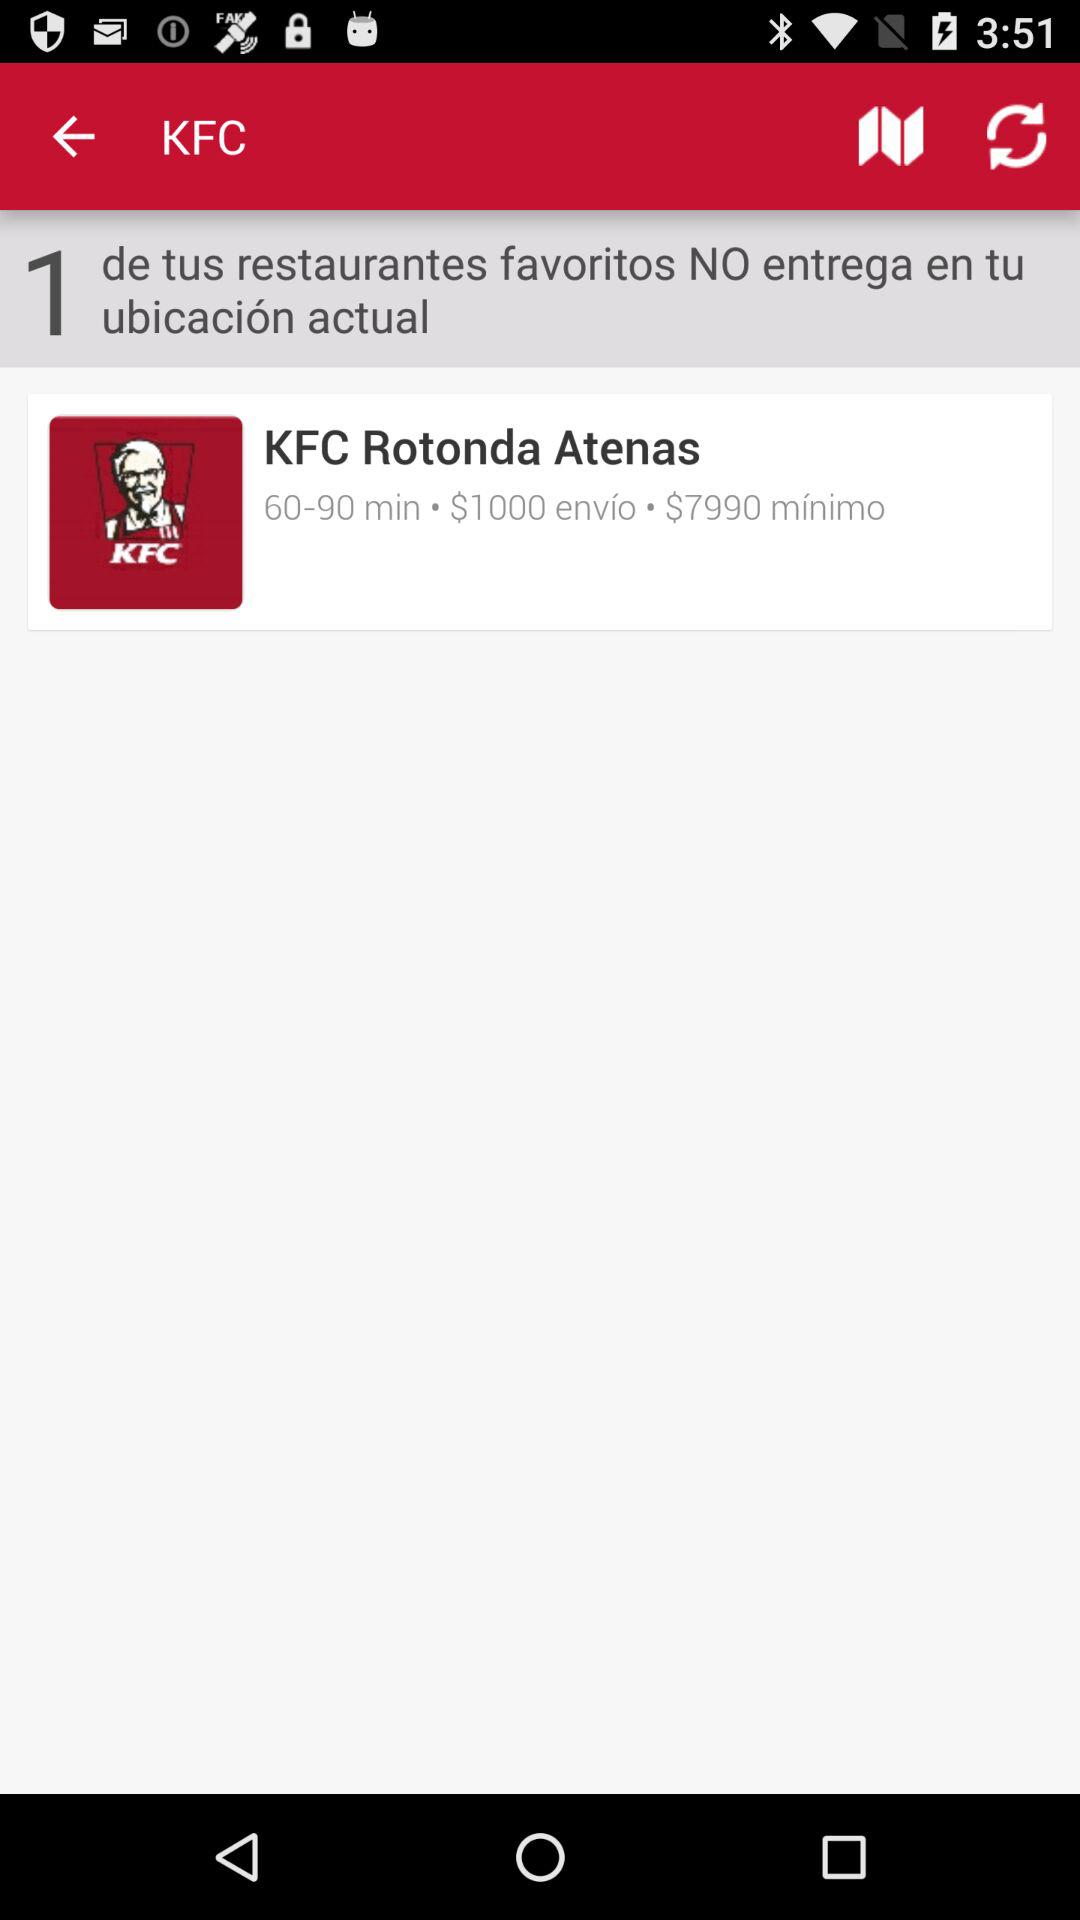How many restaurants are not delivering to my location?
Answer the question using a single word or phrase. 1 